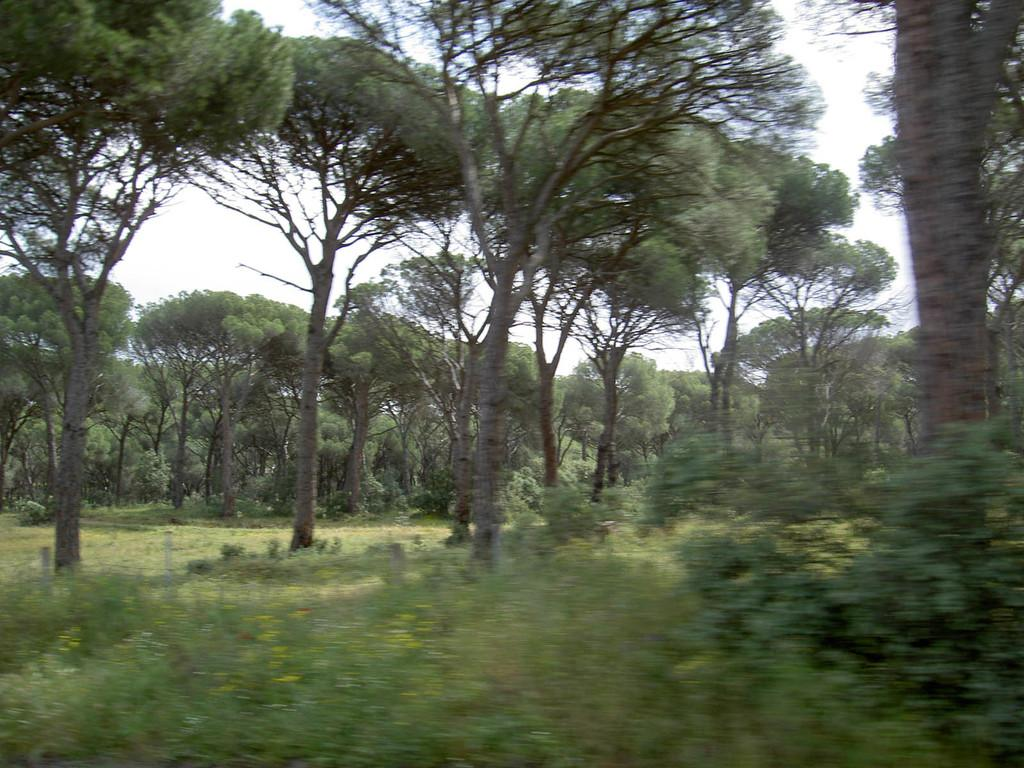What type of vegetation can be seen in the image? There are plants and trees in the image. What is covering the ground in the image? There is grass on the ground in the image. What can be seen in the sky in the background of the image? There are clouds in the sky in the background of the image. What type of instrument is being played by the tree in the image? There is no instrument being played by a tree in the image, as trees do not have the ability to play instruments. 